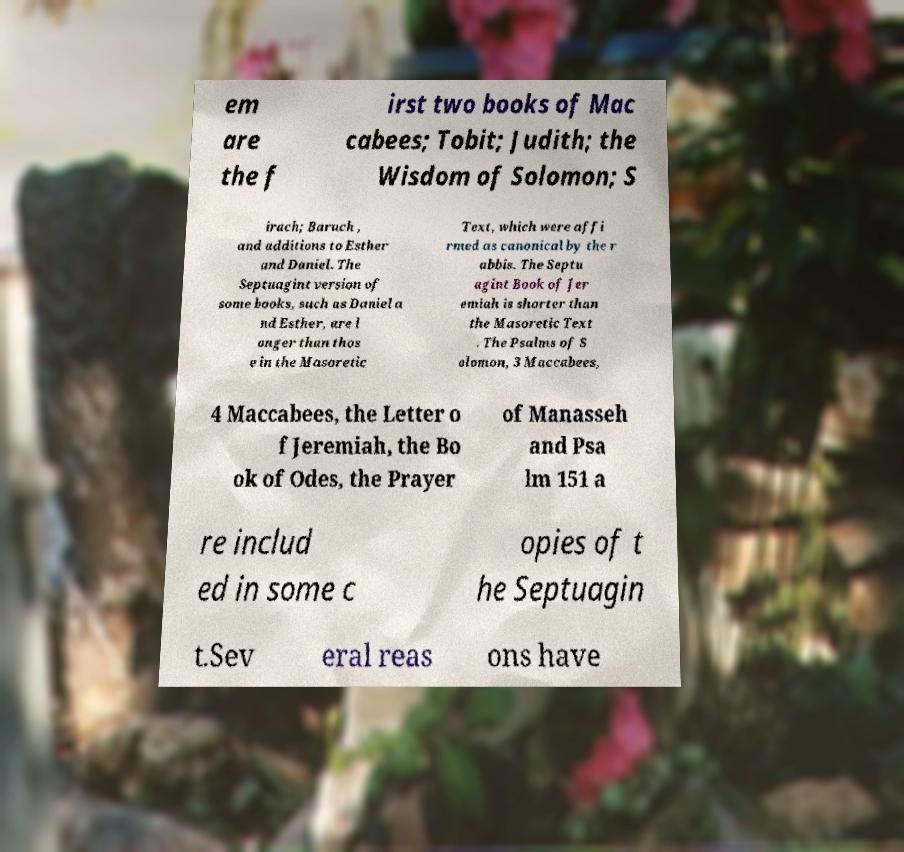I need the written content from this picture converted into text. Can you do that? em are the f irst two books of Mac cabees; Tobit; Judith; the Wisdom of Solomon; S irach; Baruch , and additions to Esther and Daniel. The Septuagint version of some books, such as Daniel a nd Esther, are l onger than thos e in the Masoretic Text, which were affi rmed as canonical by the r abbis. The Septu agint Book of Jer emiah is shorter than the Masoretic Text . The Psalms of S olomon, 3 Maccabees, 4 Maccabees, the Letter o f Jeremiah, the Bo ok of Odes, the Prayer of Manasseh and Psa lm 151 a re includ ed in some c opies of t he Septuagin t.Sev eral reas ons have 